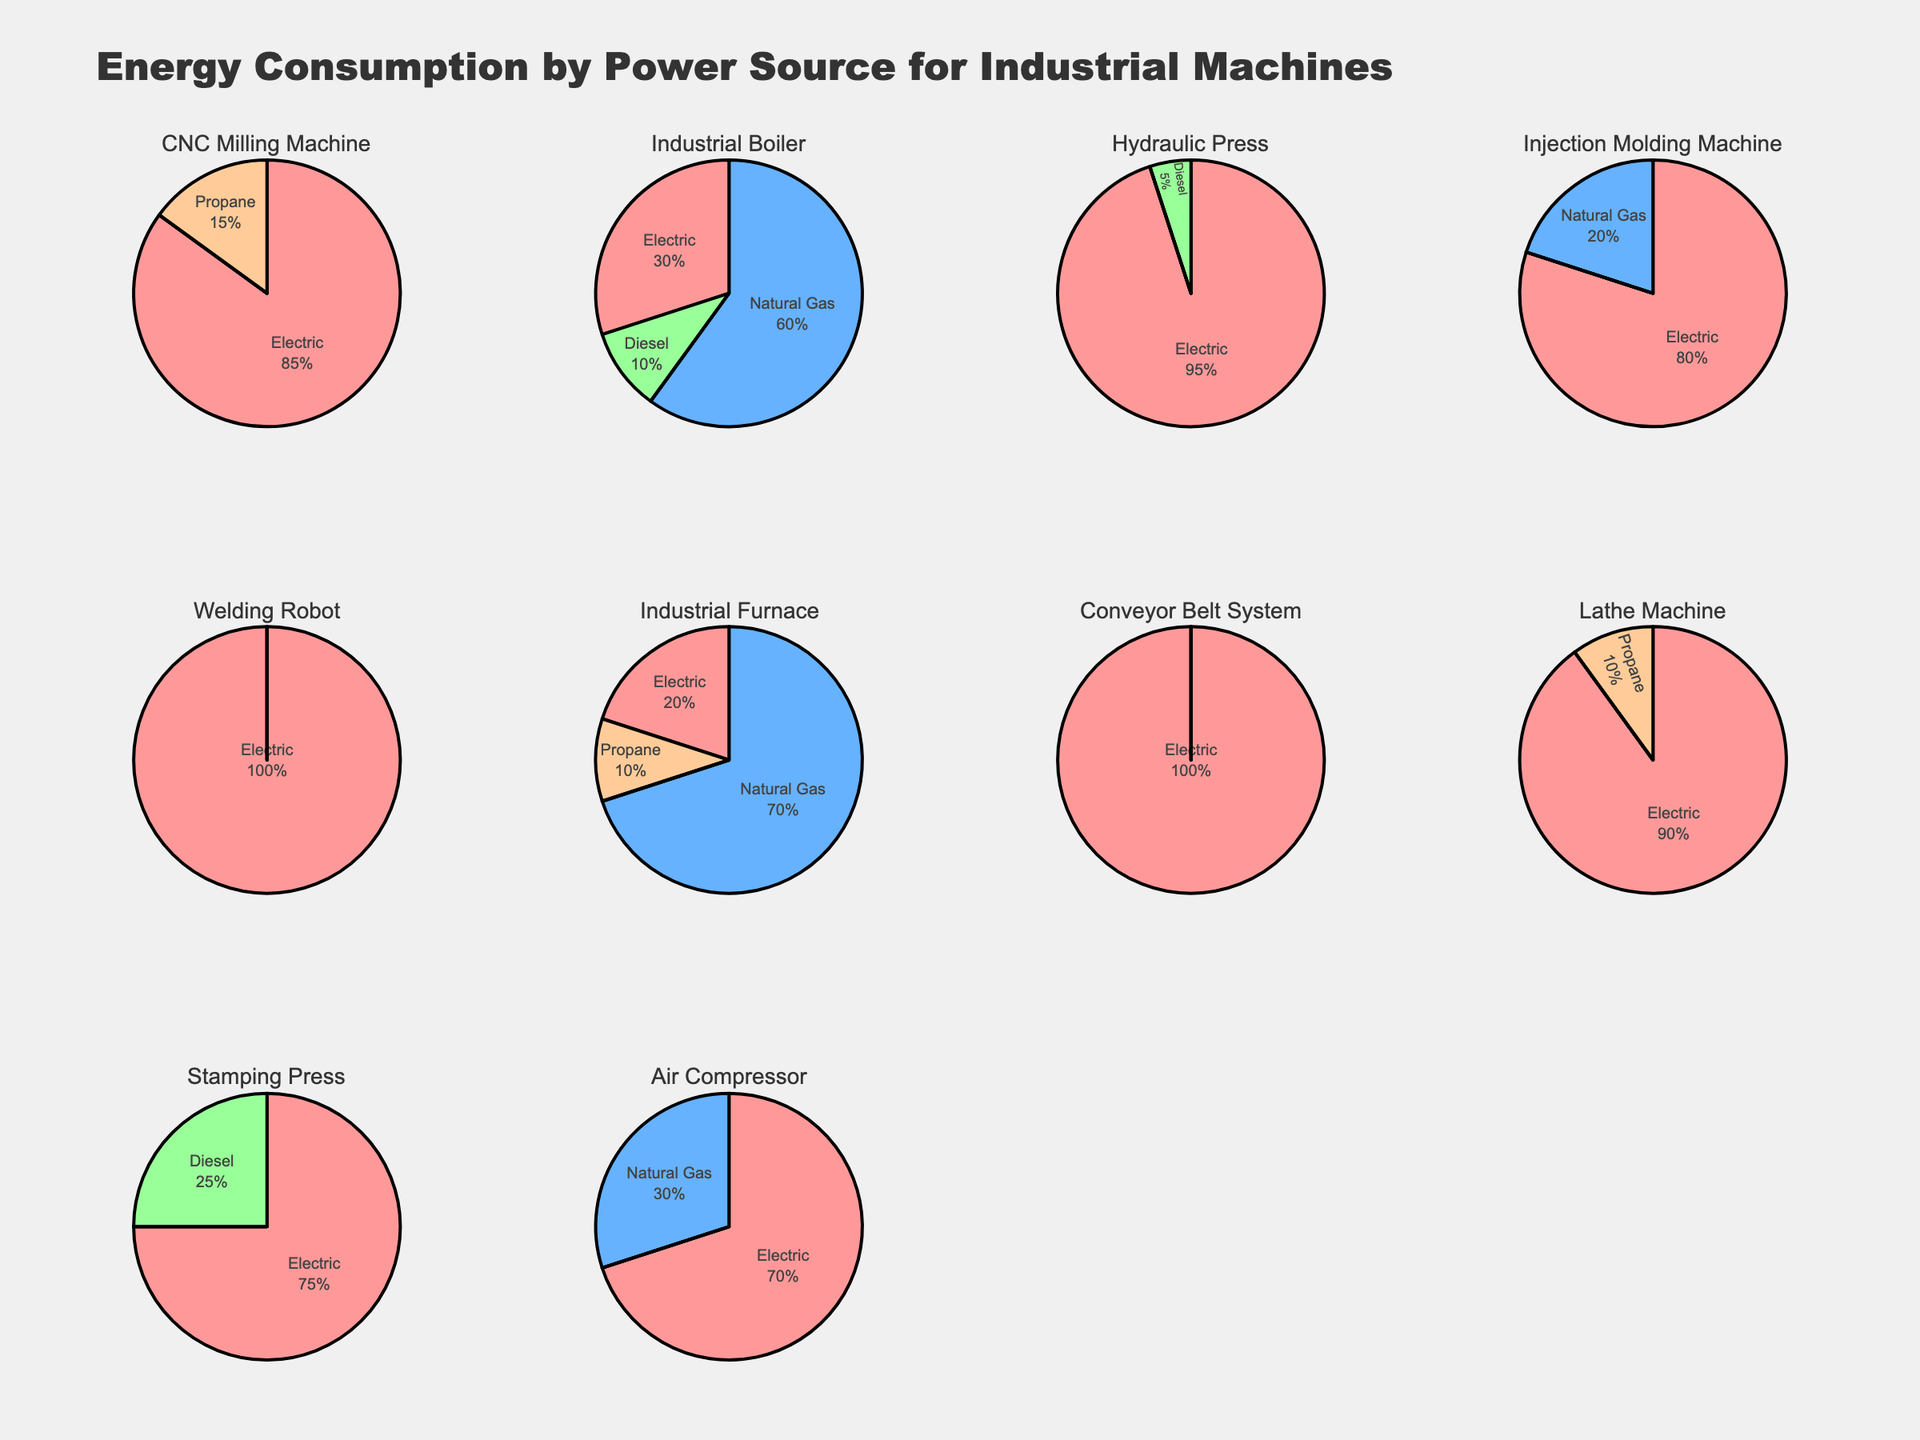What's the title of the figure? The title is located at the top of the figure and summarizes what the figure is about.
Answer: Energy Consumption by Power Source for Industrial Machines Which machine uses only electric power? By checking the pie charts, the machines that use only electric power will have 100% allocated to Electric and 0% to other sources.
Answer: Welding Robot and Conveyor Belt System Which machine has the highest usage of natural gas? Identify the machine with the largest percentage allocation to Natural Gas in the pie charts.
Answer: Industrial Furnace List all machines that use propane. Look for pie charts where the percentage allocation for Propane is greater than 0%.
Answer: CNC Milling Machine, Industrial Furnace, Lathe Machine What's the average electric consumption across all machines? Sum up the electric percentages and divide by the number of machines (10). Calculation: (85 + 30 + 95 + 80 + 100 + 20 + 100 + 90 + 75 + 70) / 10 = 74.5%
Answer: 74.5% Which machine type has the most diverse energy usage (i.e., uses the largest number of different power sources)? Count the different power sources used by each machine and identify the machine with the highest number of different sources.
Answer: Industrial Boiler (uses Electric, Natural Gas, and Diesel) How many machines use some form of fuel other than electric power? Count the pie charts that have positive percentages for Natural Gas, Diesel, or Propane.
Answer: 7 Compare electric consumption of Hydraulic Press and Lathe Machine. Which one is higher? Check the electric percentage for both machines and compare them. Hydraulic Press: 95%, Lathe Machine: 90%
Answer: Hydraulic Press What is the second most common power source for the Industrial Boiler? Look at the pie chart for Industrial Boiler and determine which power source has the second largest percentage.
Answer: Diesel 